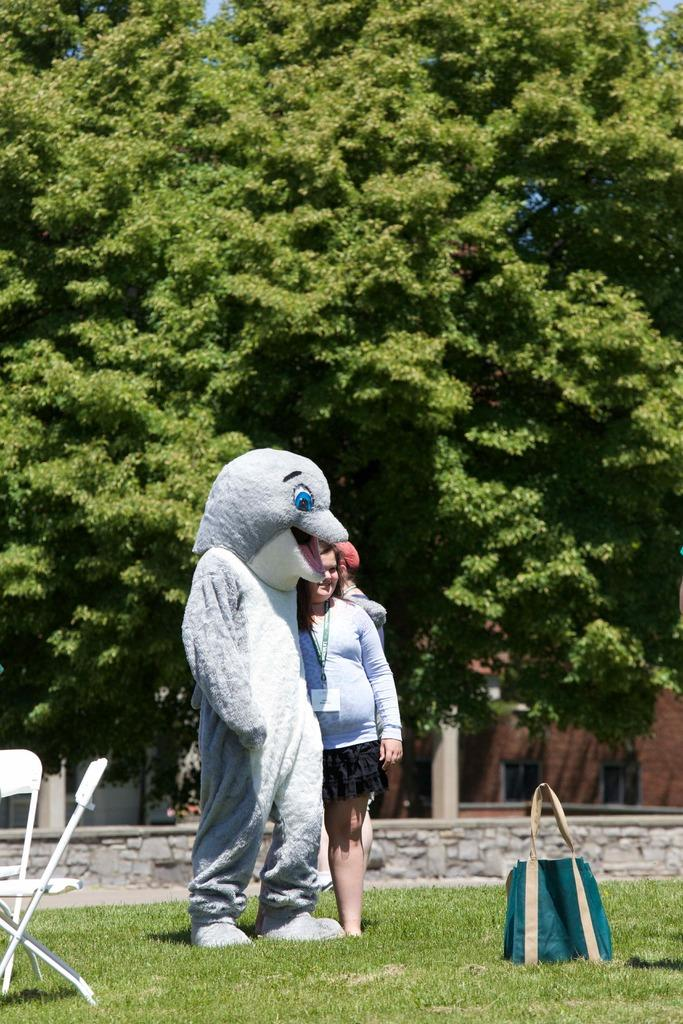What type of natural elements can be seen in the image? There are trees in the image. How many people are present in the image? There are two persons standing in the image. What type of furniture is visible in the image? There are two chairs in the image. What type of personal item can be seen in the image? There is a bag in the image. What type of voice can be heard coming from the trees in the image? There is no voice present in the image, as it is a still image and does not contain any sounds. 